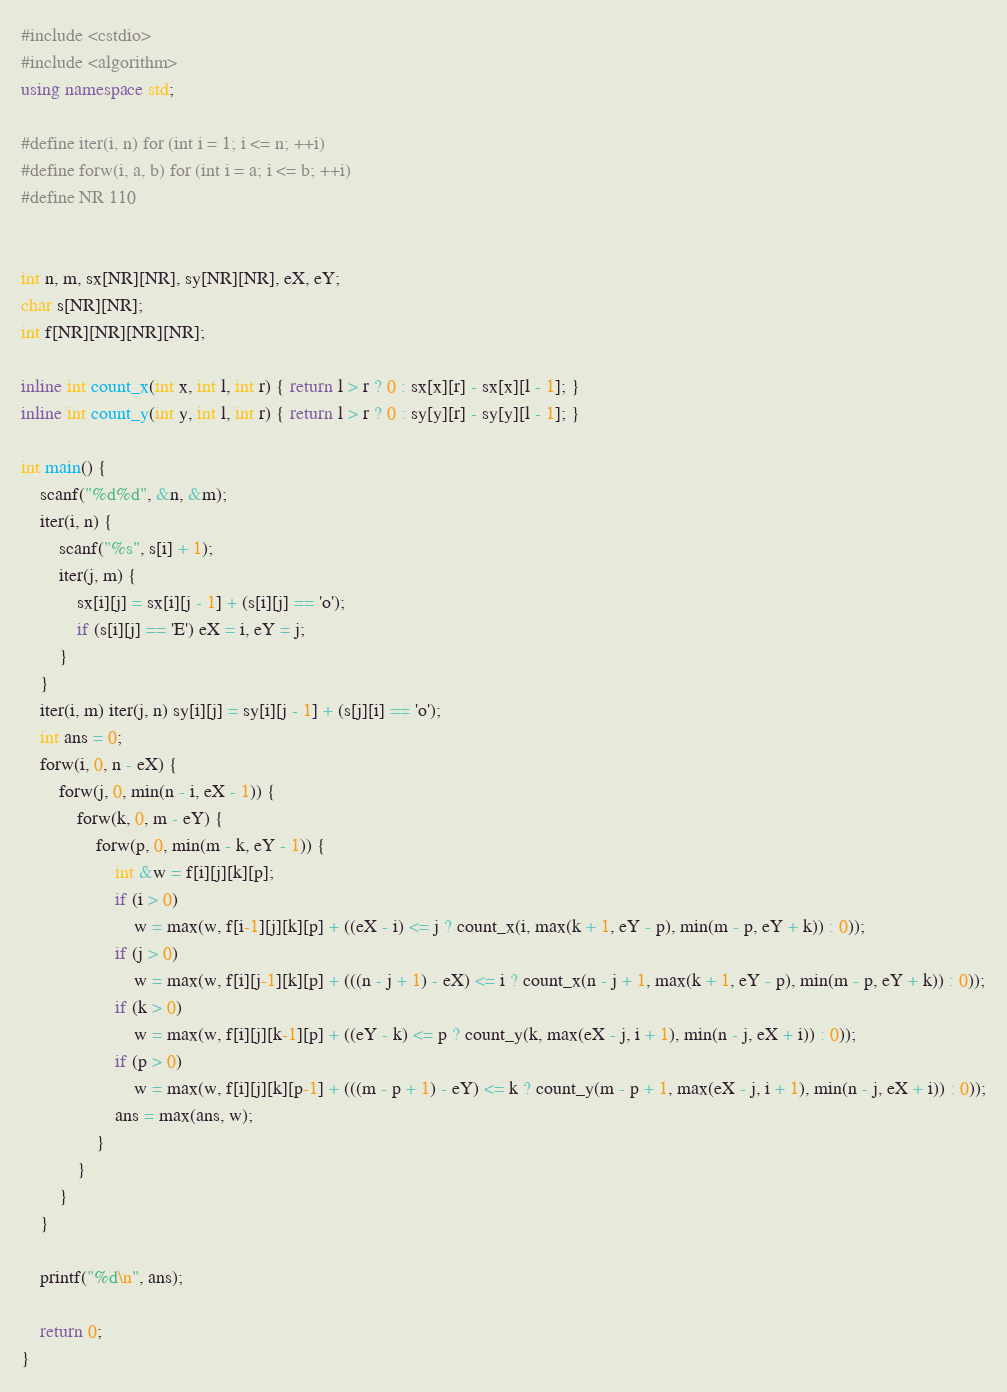Convert code to text. <code><loc_0><loc_0><loc_500><loc_500><_C++_>#include <cstdio>
#include <algorithm>
using namespace std;

#define iter(i, n) for (int i = 1; i <= n; ++i)
#define forw(i, a, b) for (int i = a; i <= b; ++i)
#define NR 110


int n, m, sx[NR][NR], sy[NR][NR], eX, eY;
char s[NR][NR];
int f[NR][NR][NR][NR];

inline int count_x(int x, int l, int r) { return l > r ? 0 : sx[x][r] - sx[x][l - 1]; }
inline int count_y(int y, int l, int r) { return l > r ? 0 : sy[y][r] - sy[y][l - 1]; }

int main() {
	scanf("%d%d", &n, &m);
	iter(i, n) {
		scanf("%s", s[i] + 1);
		iter(j, m) {
			sx[i][j] = sx[i][j - 1] + (s[i][j] == 'o');
			if (s[i][j] == 'E') eX = i, eY = j;
		}
	}
	iter(i, m) iter(j, n) sy[i][j] = sy[i][j - 1] + (s[j][i] == 'o');
	int ans = 0;
	forw(i, 0, n - eX) {
		forw(j, 0, min(n - i, eX - 1)) {
			forw(k, 0, m - eY) {
				forw(p, 0, min(m - k, eY - 1)) {
					int &w = f[i][j][k][p];
					if (i > 0)
						w = max(w, f[i-1][j][k][p] + ((eX - i) <= j ? count_x(i, max(k + 1, eY - p), min(m - p, eY + k)) : 0));
					if (j > 0)
						w = max(w, f[i][j-1][k][p] + (((n - j + 1) - eX) <= i ? count_x(n - j + 1, max(k + 1, eY - p), min(m - p, eY + k)) : 0));
					if (k > 0)
						w = max(w, f[i][j][k-1][p] + ((eY - k) <= p ? count_y(k, max(eX - j, i + 1), min(n - j, eX + i)) : 0));
					if (p > 0)
						w = max(w, f[i][j][k][p-1] + (((m - p + 1) - eY) <= k ? count_y(m - p + 1, max(eX - j, i + 1), min(n - j, eX + i)) : 0));
					ans = max(ans, w);
				}
			}
		}
	}

	printf("%d\n", ans);

	return 0;
}</code> 